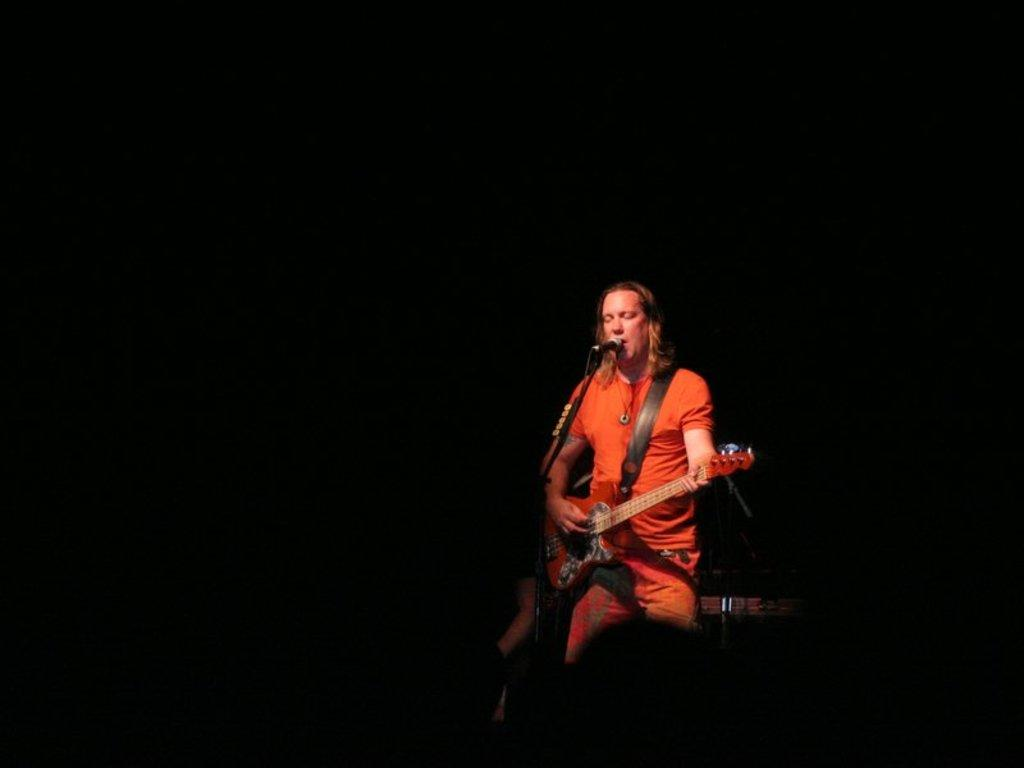What is the man in the image doing? The man is singing in the image. What is the man holding while singing? The man is holding a microphone and a guitar. What type of fork is the man using to play the guitar in the image? There is no fork present in the image, and the man is not using any utensil to play the guitar. 